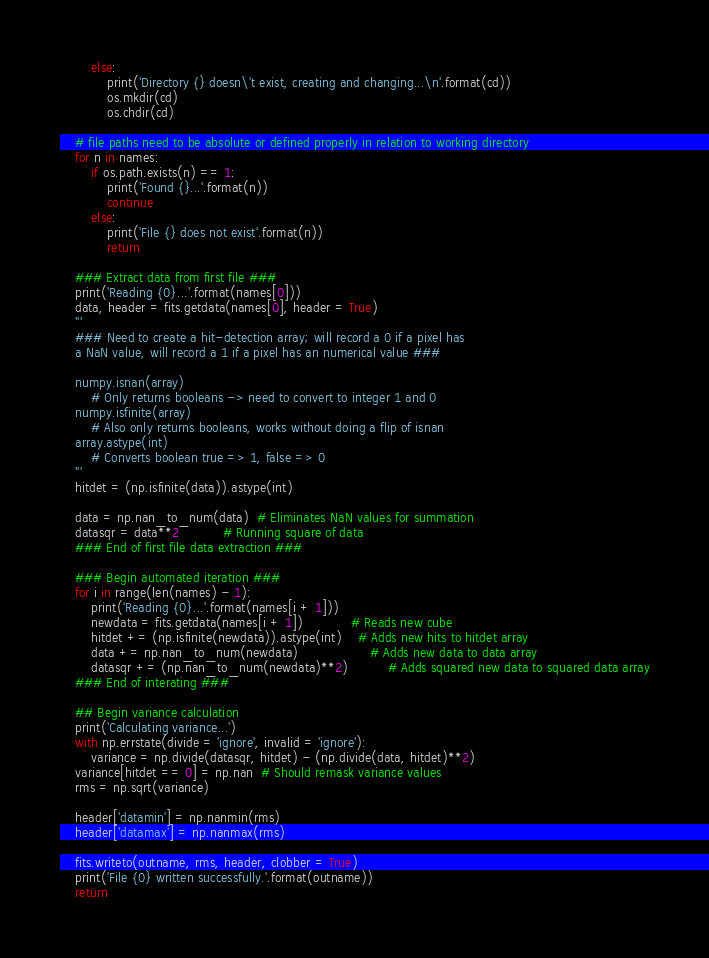Convert code to text. <code><loc_0><loc_0><loc_500><loc_500><_Python_>        else:
            print('Directory {} doesn\'t exist, creating and changing...\n'.format(cd))
            os.mkdir(cd)
            os.chdir(cd)
    
    # file paths need to be absolute or defined properly in relation to working directory
    for n in names:
        if os.path.exists(n) == 1:
            print('Found {}...'.format(n))
            continue
        else:
            print('File {} does not exist'.format(n))
            return   

    ### Extract data from first file ###
    print('Reading {0}...'.format(names[0]))
    data, header = fits.getdata(names[0], header = True)
    '''
    ### Need to create a hit-detection array; will record a 0 if a pixel has 
    a NaN value, will record a 1 if a pixel has an numerical value ###

    numpy.isnan(array)
        # Only returns booleans -> need to convert to integer 1 and 0
    numpy.isfinite(array)
        # Also only returns booleans, works without doing a flip of isnan
    array.astype(int)
        # Converts boolean true => 1, false => 0
    '''
    hitdet = (np.isfinite(data)).astype(int)

    data = np.nan_to_num(data)  # Eliminates NaN values for summation
    datasqr = data**2           # Running square of data
    ### End of first file data extraction ###

    ### Begin automated iteration ###
    for i in range(len(names) - 1):
        print('Reading {0}...'.format(names[i + 1]))
        newdata = fits.getdata(names[i + 1])            # Reads new cube
        hitdet += (np.isfinite(newdata)).astype(int)    # Adds new hits to hitdet array
        data += np.nan_to_num(newdata)                  # Adds new data to data array
        datasqr += (np.nan_to_num(newdata)**2)          # Adds squared new data to squared data array
    ### End of interating ###

    ## Begin variance calculation
    print('Calculating variance...')
    with np.errstate(divide = 'ignore', invalid = 'ignore'):
        variance = np.divide(datasqr, hitdet) - (np.divide(data, hitdet)**2)
    variance[hitdet == 0] = np.nan  # Should remask variance values
    rms = np.sqrt(variance)

    header['datamin'] = np.nanmin(rms)
    header['datamax'] = np.nanmax(rms)

    fits.writeto(outname, rms, header, clobber = True)
    print('File {0} written successfully.'.format(outname))
    return
</code> 